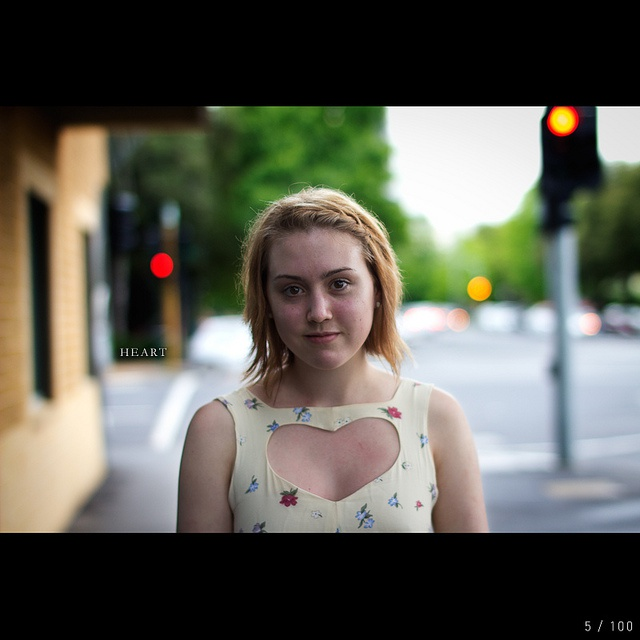Describe the objects in this image and their specific colors. I can see people in black, darkgray, gray, and lightgray tones, traffic light in black, gold, red, and orange tones, and traffic light in black, red, maroon, and brown tones in this image. 